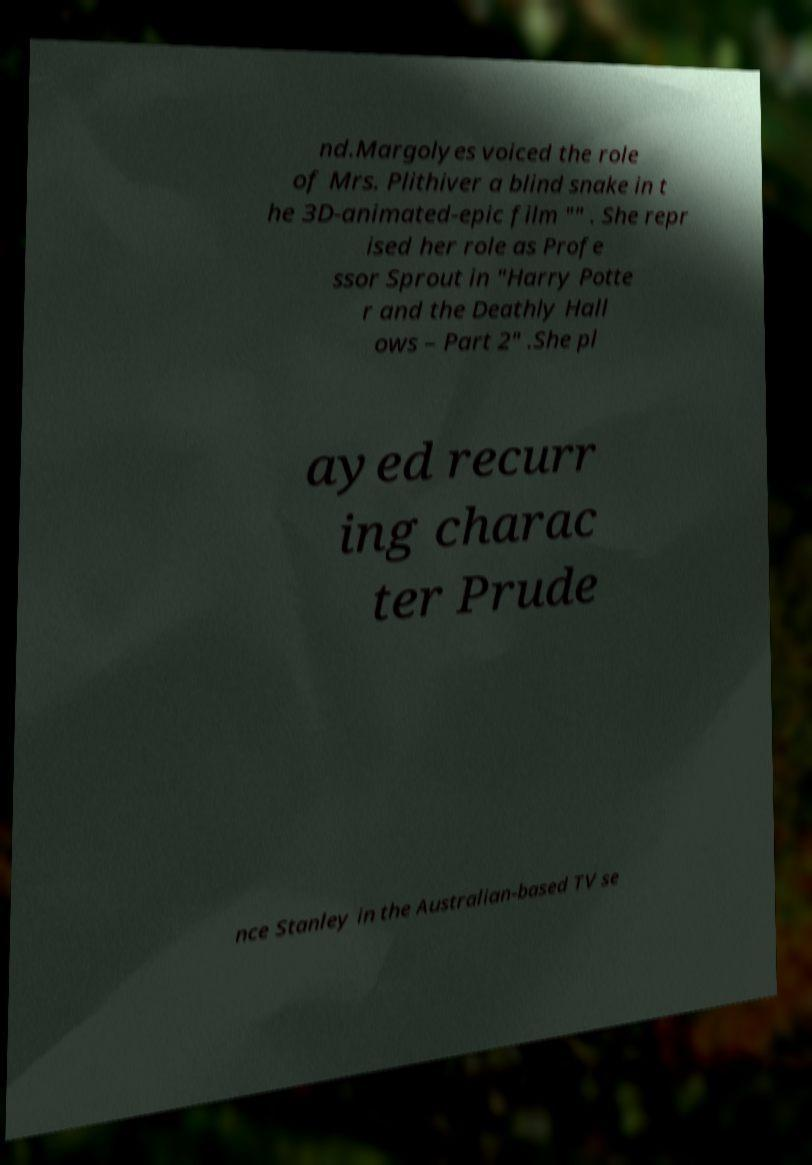Please read and relay the text visible in this image. What does it say? nd.Margolyes voiced the role of Mrs. Plithiver a blind snake in t he 3D-animated-epic film "" . She repr ised her role as Profe ssor Sprout in "Harry Potte r and the Deathly Hall ows – Part 2" .She pl ayed recurr ing charac ter Prude nce Stanley in the Australian-based TV se 